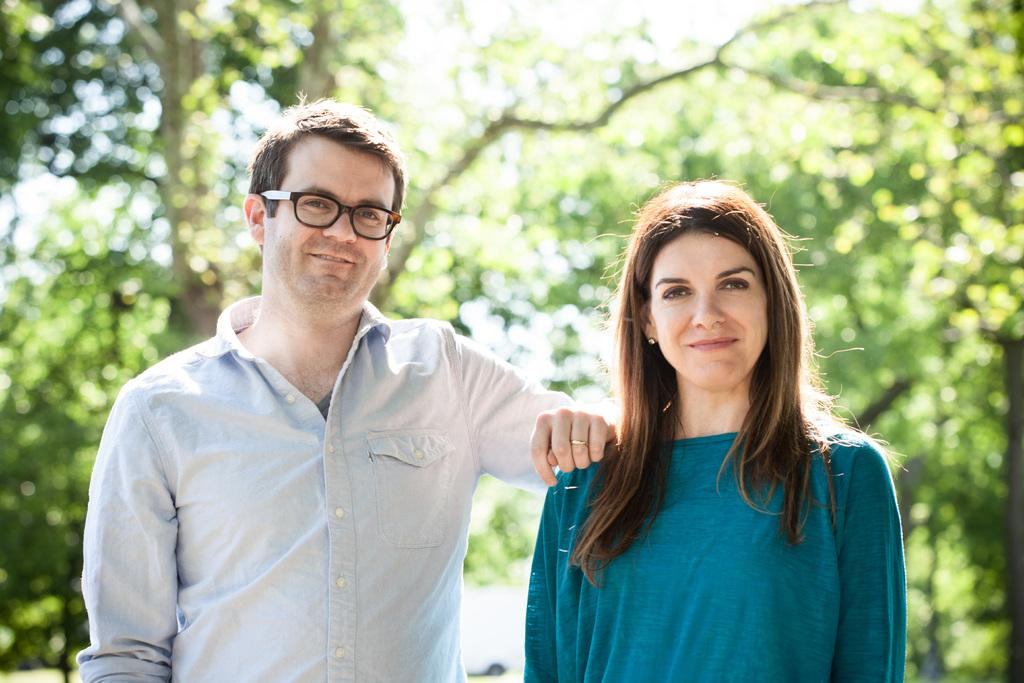Where was the image taken? The image is taken outdoors. What can be seen in the background of the image? There are trees in the background of the image. Who are the people in the image? A man and a woman are standing in the middle of the image. What is the facial expression of the man and the woman? The man and the woman are smiling. What invention is being demonstrated by the man and woman in the image? There is no invention being demonstrated in the image; it simply shows a man and a woman standing and smiling. Can you tell me how deep the ocean is in the image? There is no ocean present in the image; it is taken outdoors with trees in the background. 